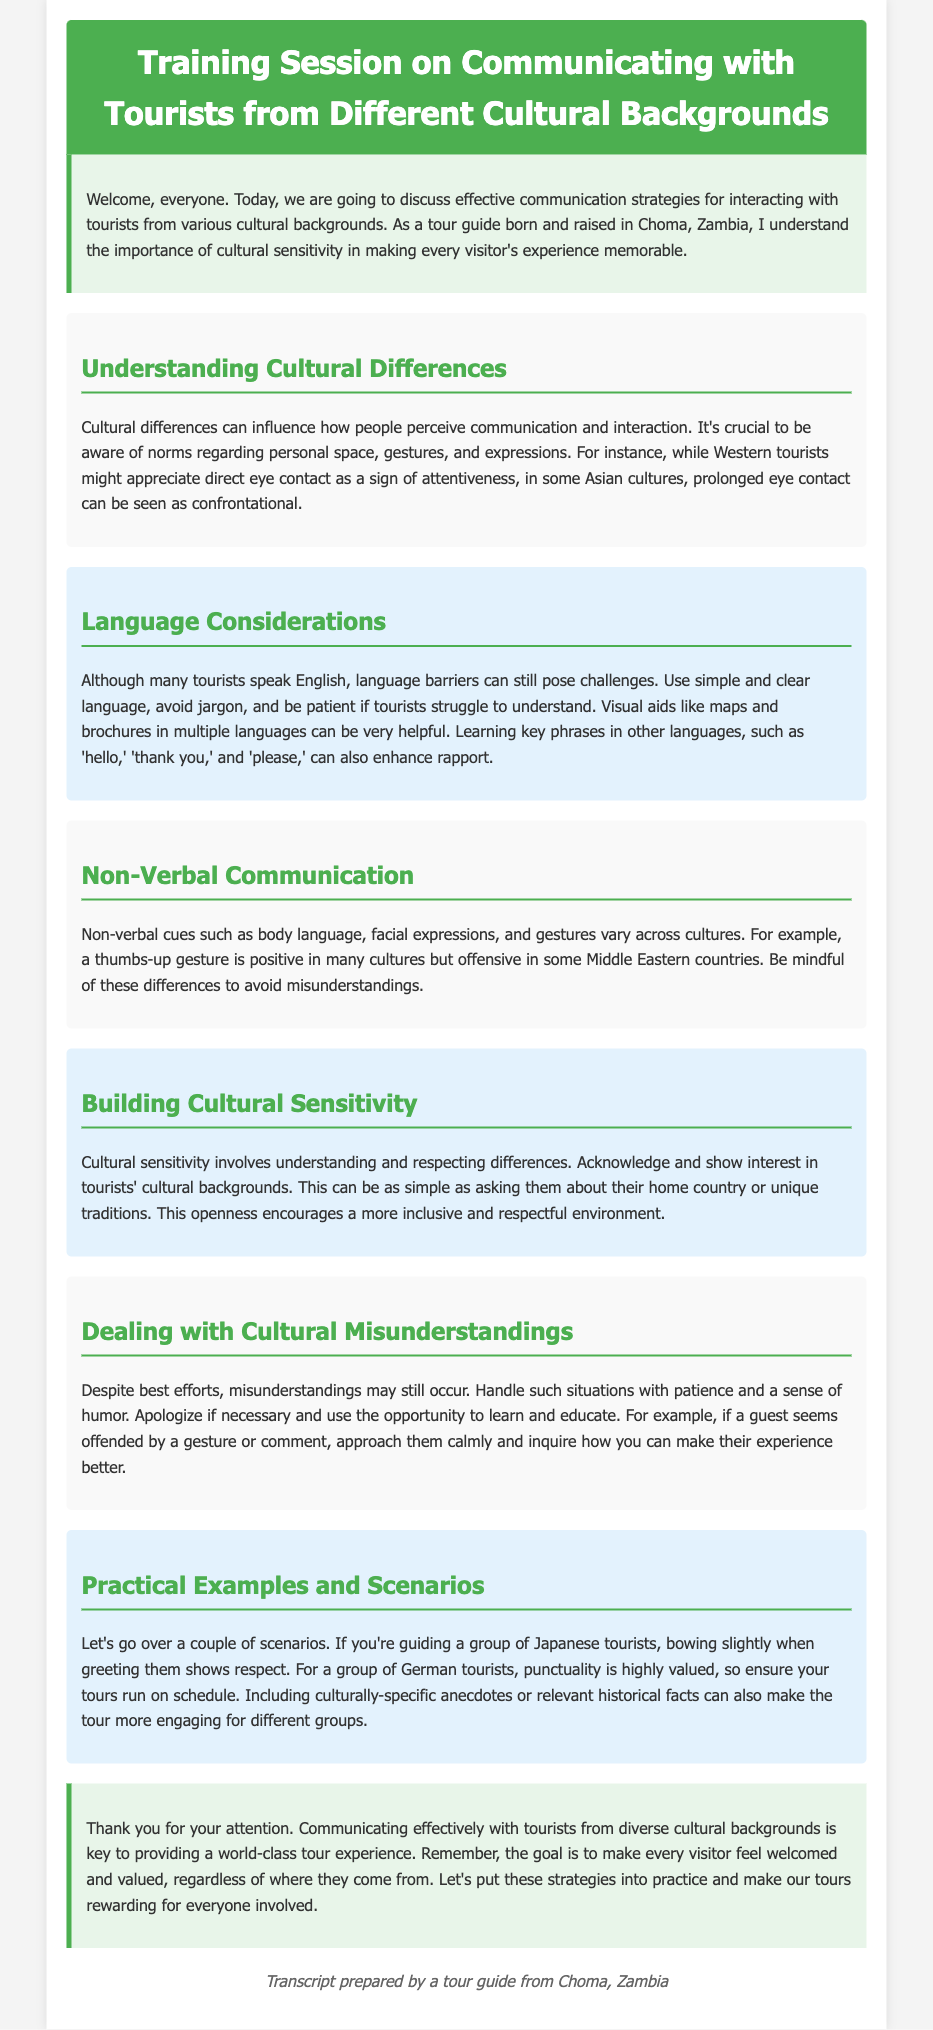What is the title of the training session? The title of the training session is mentioned in the header of the document.
Answer: Training Session on Communicating with Tourists from Different Cultural Backgrounds What is a key aspect of understanding cultural differences? This aspect is highlighted in the section discussing cultural differences, specifically regarding perceptions of communication and interaction.
Answer: Personal space What does cultural sensitivity involve? Cultural sensitivity is defined in the section about building cultural sensitivity and involves understanding and respecting differences.
Answer: Understanding and respecting differences Which gesture is positive in many cultures but offensive in some Middle Eastern countries? The document mentions specific gestures and their cultural interpretations in the section on non-verbal communication.
Answer: Thumbs-up What should you do if a cultural misunderstanding occurs? This suggestion is provided in the section on dealing with cultural misunderstandings and includes a recommended approach.
Answer: Handle with patience and a sense of humor How should you greet Japanese tourists to show respect? This information is provided as a practical example in the section about practical examples and scenarios.
Answer: Bowing slightly What language considerations should be made when communicating with tourists? The document outlines important considerations regarding language in a dedicated section.
Answer: Use simple and clear language What is the importance of visual aids according to the training? The importance is detailed in the language considerations section, emphasizing their role in communication.
Answer: Helpful 